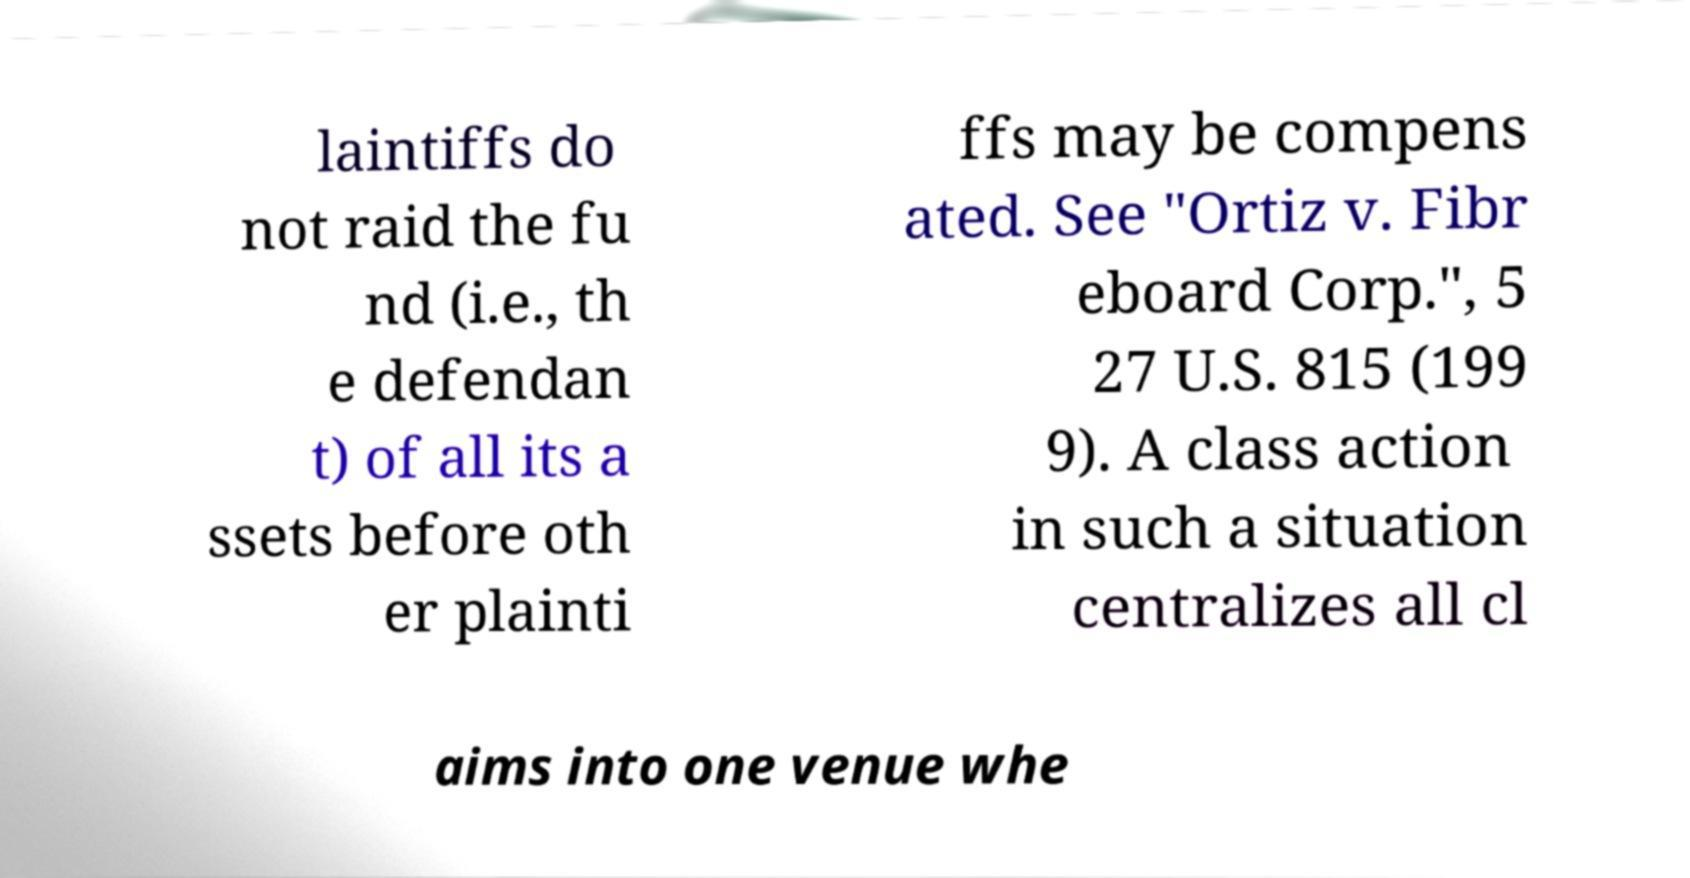Could you assist in decoding the text presented in this image and type it out clearly? laintiffs do not raid the fu nd (i.e., th e defendan t) of all its a ssets before oth er plainti ffs may be compens ated. See "Ortiz v. Fibr eboard Corp.", 5 27 U.S. 815 (199 9). A class action in such a situation centralizes all cl aims into one venue whe 